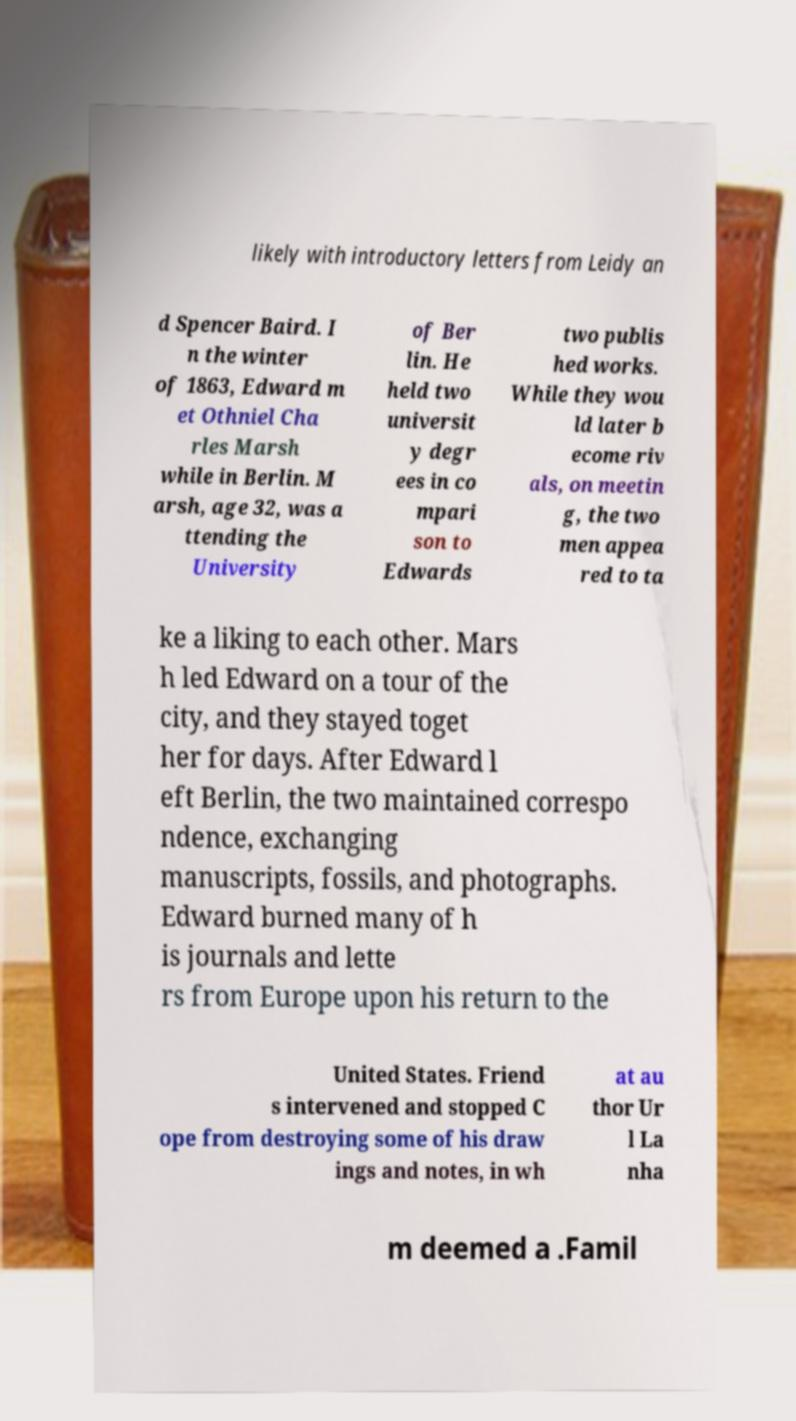I need the written content from this picture converted into text. Can you do that? likely with introductory letters from Leidy an d Spencer Baird. I n the winter of 1863, Edward m et Othniel Cha rles Marsh while in Berlin. M arsh, age 32, was a ttending the University of Ber lin. He held two universit y degr ees in co mpari son to Edwards two publis hed works. While they wou ld later b ecome riv als, on meetin g, the two men appea red to ta ke a liking to each other. Mars h led Edward on a tour of the city, and they stayed toget her for days. After Edward l eft Berlin, the two maintained correspo ndence, exchanging manuscripts, fossils, and photographs. Edward burned many of h is journals and lette rs from Europe upon his return to the United States. Friend s intervened and stopped C ope from destroying some of his draw ings and notes, in wh at au thor Ur l La nha m deemed a .Famil 